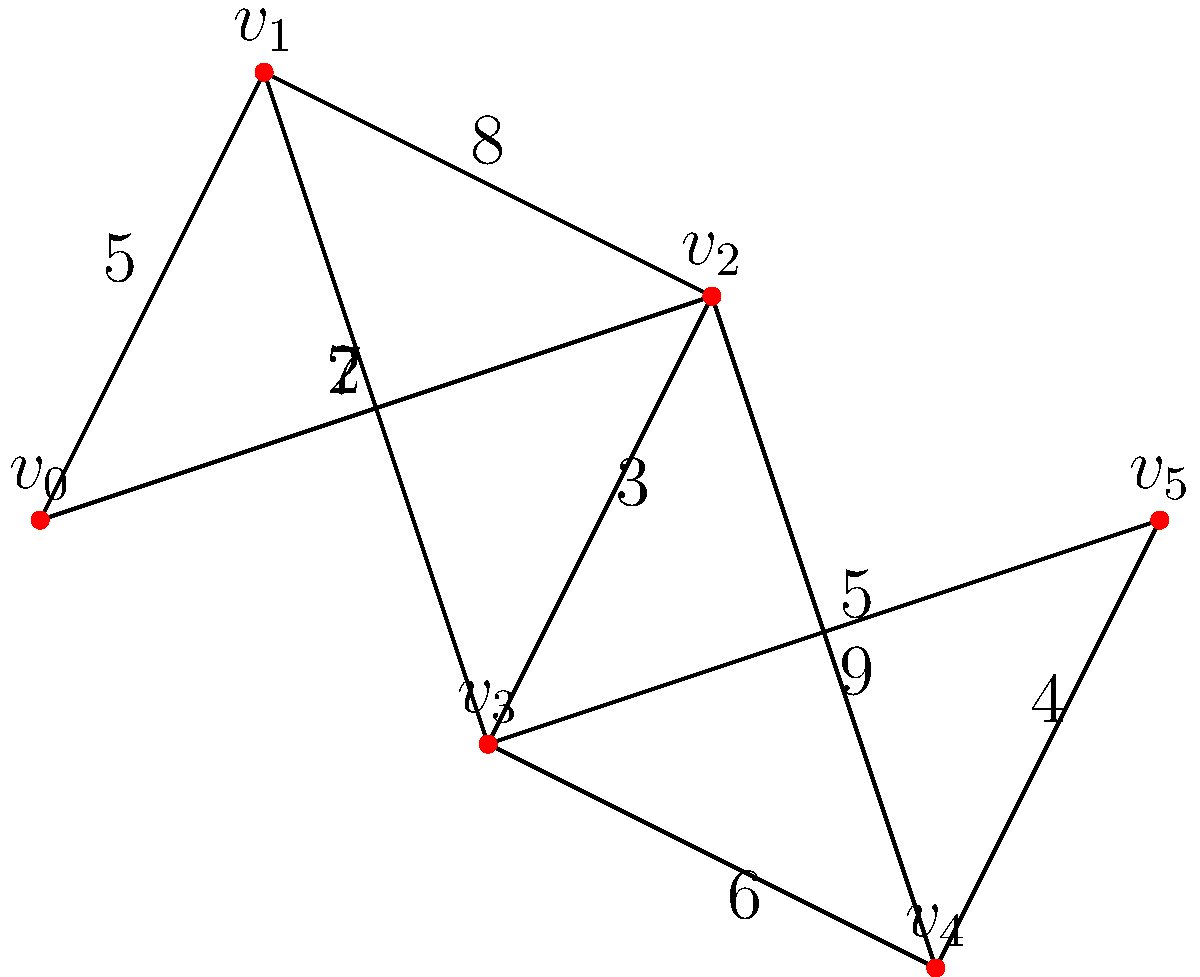As a music producer organizing a large international music festival, you need to determine the most efficient cable routing for the sound system. The festival grounds are represented by the graph above, where vertices represent stage locations and edges represent potential cable routes with their respective lengths (in meters). What is the total length of cable needed to connect all stages using the minimum spanning tree algorithm? To find the minimum spanning tree (MST) of this graph, we'll use Kruskal's algorithm:

1. Sort all edges by weight in ascending order:
   $(v_1,v_3): 2$, $(v_2,v_3): 3$, $(v_4,v_5): 4$, $(v_0,v_1): 5$, $(v_3,v_5): 5$, $(v_3,v_4): 6$, $(v_0,v_2): 7$, $(v_1,v_2): 8$, $(v_2,v_4): 9$

2. Start with an empty MST and add edges in order, skipping those that would create a cycle:
   - Add $(v_1,v_3): 2$
   - Add $(v_2,v_3): 3$
   - Add $(v_4,v_5): 4$
   - Add $(v_0,v_1): 5$
   - Add $(v_3,v_5): 5$ (skipped, would create a cycle)
   - Add $(v_3,v_4): 6$

3. The MST is now complete with 5 edges (for 6 vertices).

4. Sum the weights of the edges in the MST:
   $2 + 3 + 4 + 5 + 6 = 20$

Therefore, the total length of cable needed is 20 meters.
Answer: 20 meters 